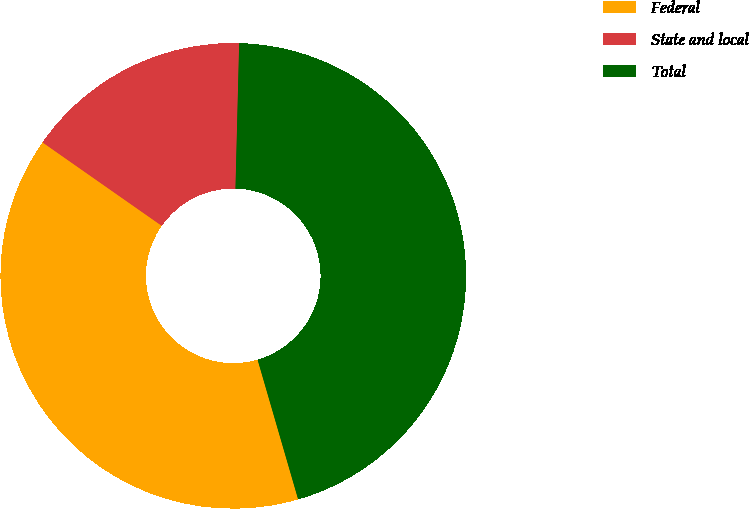Convert chart to OTSL. <chart><loc_0><loc_0><loc_500><loc_500><pie_chart><fcel>Federal<fcel>State and local<fcel>Total<nl><fcel>39.22%<fcel>15.69%<fcel>45.1%<nl></chart> 